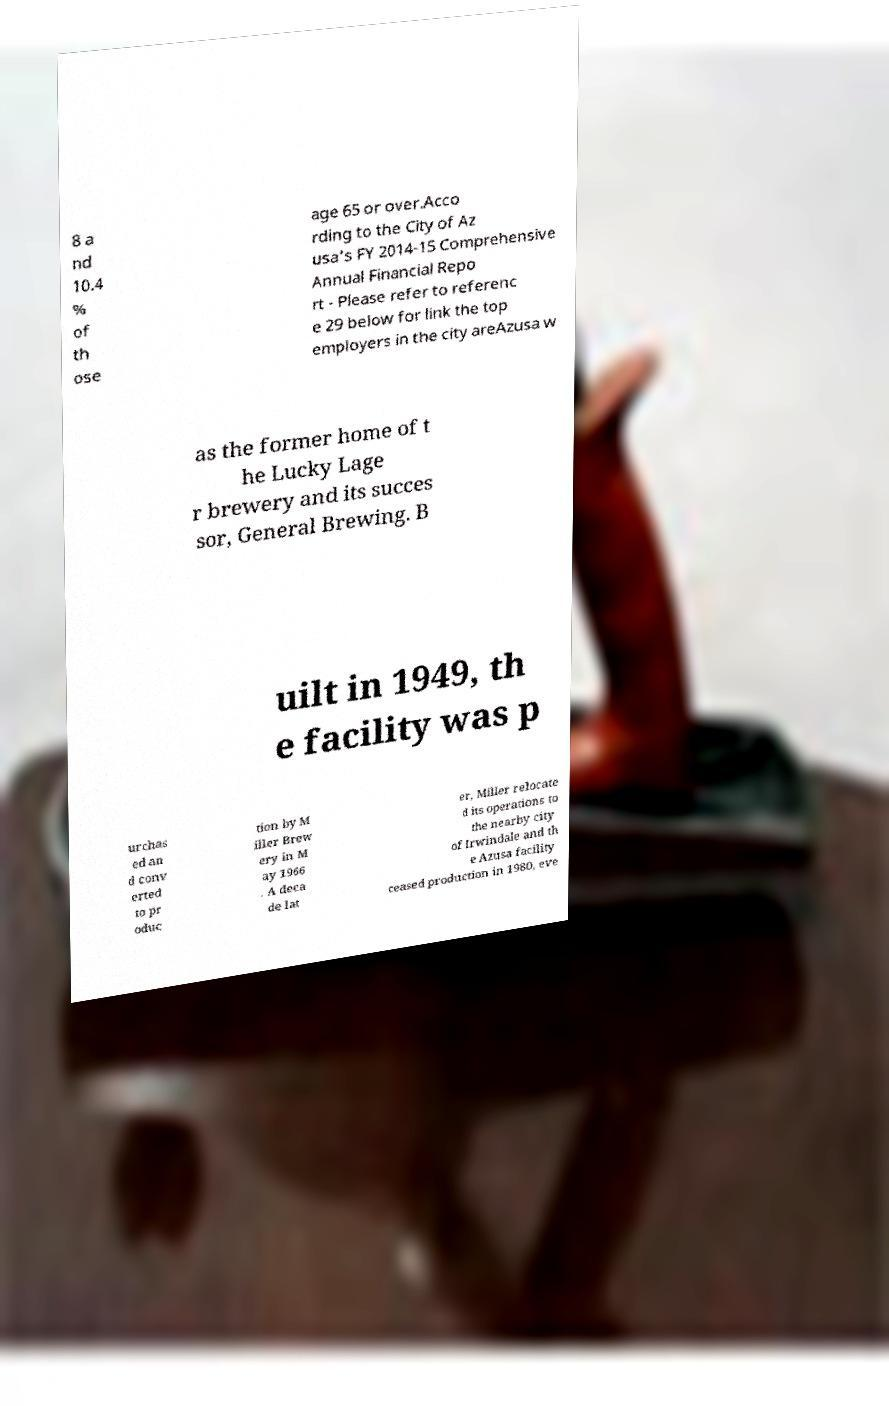Please identify and transcribe the text found in this image. 8 a nd 10.4 % of th ose age 65 or over.Acco rding to the City of Az usa's FY 2014-15 Comprehensive Annual Financial Repo rt - Please refer to referenc e 29 below for link the top employers in the city areAzusa w as the former home of t he Lucky Lage r brewery and its succes sor, General Brewing. B uilt in 1949, th e facility was p urchas ed an d conv erted to pr oduc tion by M iller Brew ery in M ay 1966 . A deca de lat er, Miller relocate d its operations to the nearby city of Irwindale and th e Azusa facility ceased production in 1980, eve 